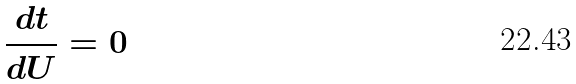Convert formula to latex. <formula><loc_0><loc_0><loc_500><loc_500>\frac { d t } { d U } = 0</formula> 